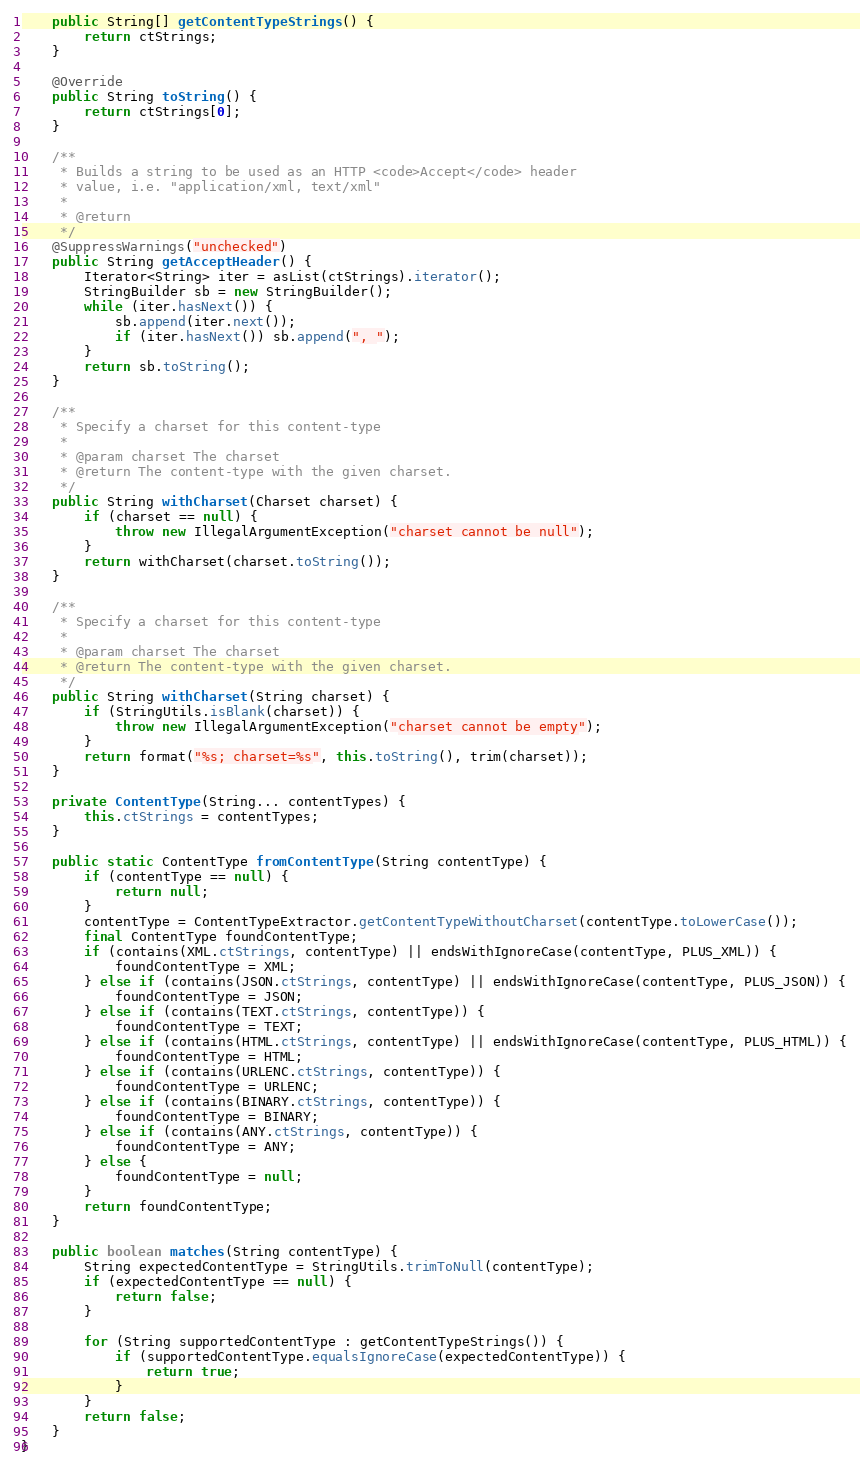Convert code to text. <code><loc_0><loc_0><loc_500><loc_500><_Java_>
    public String[] getContentTypeStrings() {
        return ctStrings;
    }

    @Override
    public String toString() {
        return ctStrings[0];
    }

    /**
     * Builds a string to be used as an HTTP <code>Accept</code> header
     * value, i.e. "application/xml, text/xml"
     *
     * @return
     */
    @SuppressWarnings("unchecked")
    public String getAcceptHeader() {
        Iterator<String> iter = asList(ctStrings).iterator();
        StringBuilder sb = new StringBuilder();
        while (iter.hasNext()) {
            sb.append(iter.next());
            if (iter.hasNext()) sb.append(", ");
        }
        return sb.toString();
    }

    /**
     * Specify a charset for this content-type
     *
     * @param charset The charset
     * @return The content-type with the given charset.
     */
    public String withCharset(Charset charset) {
        if (charset == null) {
            throw new IllegalArgumentException("charset cannot be null");
        }
        return withCharset(charset.toString());
    }

    /**
     * Specify a charset for this content-type
     *
     * @param charset The charset
     * @return The content-type with the given charset.
     */
    public String withCharset(String charset) {
        if (StringUtils.isBlank(charset)) {
            throw new IllegalArgumentException("charset cannot be empty");
        }
        return format("%s; charset=%s", this.toString(), trim(charset));
    }

    private ContentType(String... contentTypes) {
        this.ctStrings = contentTypes;
    }

    public static ContentType fromContentType(String contentType) {
        if (contentType == null) {
            return null;
        }
        contentType = ContentTypeExtractor.getContentTypeWithoutCharset(contentType.toLowerCase());
        final ContentType foundContentType;
        if (contains(XML.ctStrings, contentType) || endsWithIgnoreCase(contentType, PLUS_XML)) {
            foundContentType = XML;
        } else if (contains(JSON.ctStrings, contentType) || endsWithIgnoreCase(contentType, PLUS_JSON)) {
            foundContentType = JSON;
        } else if (contains(TEXT.ctStrings, contentType)) {
            foundContentType = TEXT;
        } else if (contains(HTML.ctStrings, contentType) || endsWithIgnoreCase(contentType, PLUS_HTML)) {
            foundContentType = HTML;
        } else if (contains(URLENC.ctStrings, contentType)) {
            foundContentType = URLENC;
        } else if (contains(BINARY.ctStrings, contentType)) {
            foundContentType = BINARY;
        } else if (contains(ANY.ctStrings, contentType)) {
            foundContentType = ANY;
        } else {
            foundContentType = null;
        }
        return foundContentType;
    }

    public boolean matches(String contentType) {
        String expectedContentType = StringUtils.trimToNull(contentType);
        if (expectedContentType == null) {
            return false;
        }

        for (String supportedContentType : getContentTypeStrings()) {
            if (supportedContentType.equalsIgnoreCase(expectedContentType)) {
                return true;
            }
        }
        return false;
    }
}
</code> 